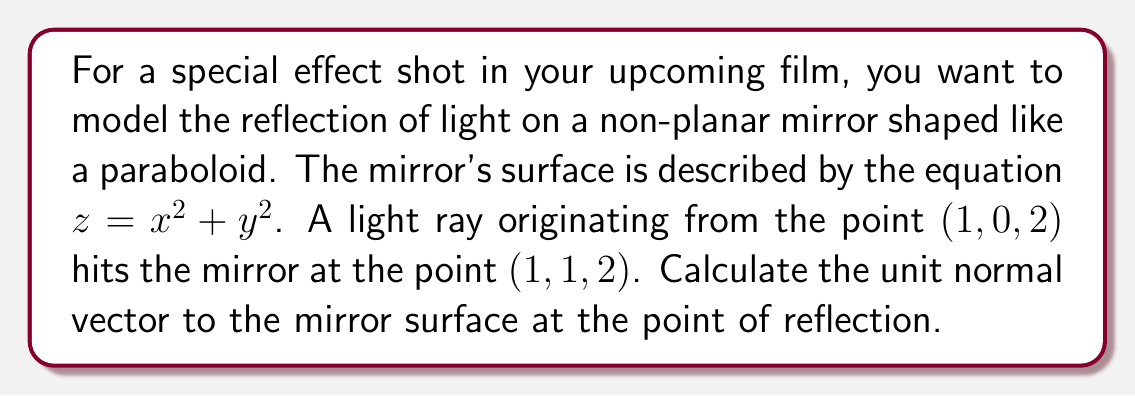Teach me how to tackle this problem. To find the unit normal vector to the mirror surface at the point of reflection, we'll follow these steps:

1) First, we need to find the gradient of the surface at the point of reflection. The gradient will give us the normal vector (not necessarily unit length).

   The surface is described by $f(x,y,z) = z - x^2 - y^2 = 0$

   The gradient is:
   $$\nabla f = \left(\frac{\partial f}{\partial x}, \frac{\partial f}{\partial y}, \frac{\partial f}{\partial z}\right) = (-2x, -2y, 1)$$

2) At the point of reflection $(1, 1, 2)$, the normal vector is:
   $$\vec{n} = (-2(1), -2(1), 1) = (-2, -2, 1)$$

3) To get the unit normal vector, we need to divide this vector by its magnitude:

   The magnitude is:
   $$|\vec{n}| = \sqrt{(-2)^2 + (-2)^2 + 1^2} = \sqrt{4 + 4 + 1} = \sqrt{9} = 3$$

4) The unit normal vector is therefore:
   $$\hat{n} = \frac{\vec{n}}{|\vec{n}|} = \frac{1}{3}(-2, -2, 1)$$

5) Simplifying:
   $$\hat{n} = \left(-\frac{2}{3}, -\frac{2}{3}, \frac{1}{3}\right)$$
Answer: The unit normal vector to the mirror surface at the point of reflection $(1, 1, 2)$ is $\left(-\frac{2}{3}, -\frac{2}{3}, \frac{1}{3}\right)$. 